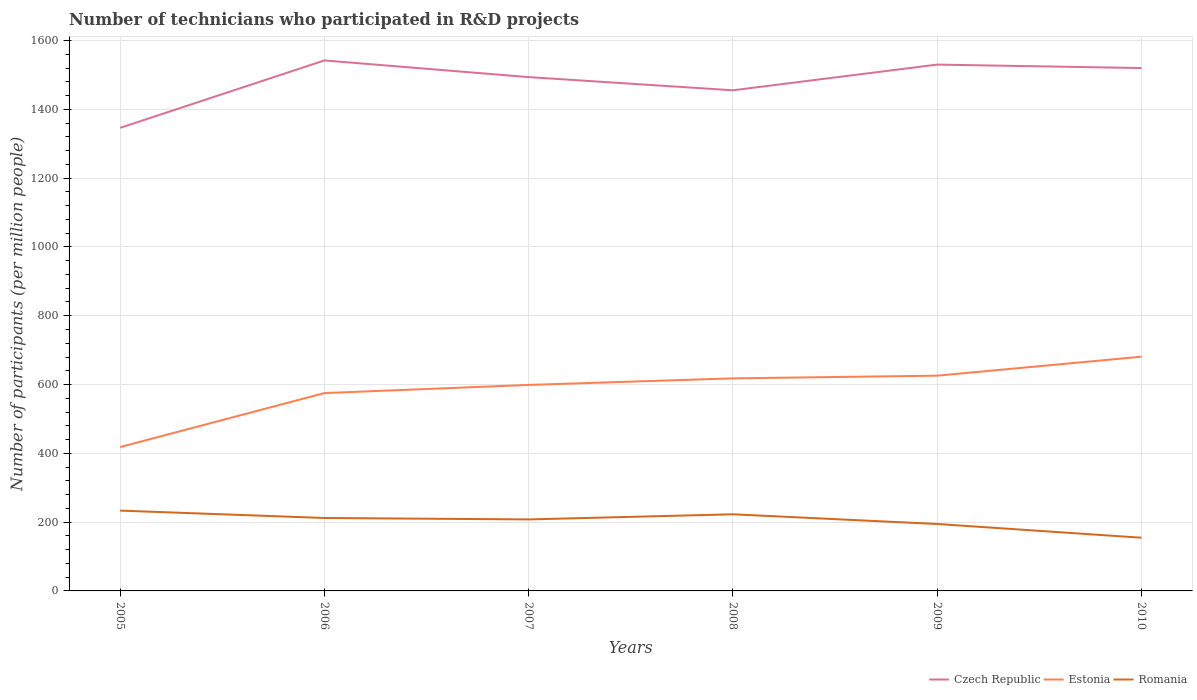How many different coloured lines are there?
Give a very brief answer. 3. Does the line corresponding to Estonia intersect with the line corresponding to Czech Republic?
Your response must be concise. No. Across all years, what is the maximum number of technicians who participated in R&D projects in Estonia?
Provide a short and direct response. 418.25. In which year was the number of technicians who participated in R&D projects in Estonia maximum?
Give a very brief answer. 2005. What is the total number of technicians who participated in R&D projects in Romania in the graph?
Make the answer very short. 68.1. What is the difference between the highest and the second highest number of technicians who participated in R&D projects in Czech Republic?
Provide a succinct answer. 195.97. What is the difference between the highest and the lowest number of technicians who participated in R&D projects in Czech Republic?
Make the answer very short. 4. Is the number of technicians who participated in R&D projects in Estonia strictly greater than the number of technicians who participated in R&D projects in Czech Republic over the years?
Keep it short and to the point. Yes. How many lines are there?
Provide a short and direct response. 3. Are the values on the major ticks of Y-axis written in scientific E-notation?
Keep it short and to the point. No. Where does the legend appear in the graph?
Your answer should be very brief. Bottom right. How many legend labels are there?
Your response must be concise. 3. How are the legend labels stacked?
Offer a very short reply. Horizontal. What is the title of the graph?
Provide a succinct answer. Number of technicians who participated in R&D projects. Does "Tanzania" appear as one of the legend labels in the graph?
Your response must be concise. No. What is the label or title of the Y-axis?
Give a very brief answer. Number of participants (per million people). What is the Number of participants (per million people) of Czech Republic in 2005?
Provide a short and direct response. 1346.19. What is the Number of participants (per million people) in Estonia in 2005?
Your response must be concise. 418.25. What is the Number of participants (per million people) of Romania in 2005?
Provide a succinct answer. 233.47. What is the Number of participants (per million people) of Czech Republic in 2006?
Make the answer very short. 1542.15. What is the Number of participants (per million people) in Estonia in 2006?
Your answer should be very brief. 575.08. What is the Number of participants (per million people) in Romania in 2006?
Offer a terse response. 212.02. What is the Number of participants (per million people) of Czech Republic in 2007?
Provide a succinct answer. 1493.68. What is the Number of participants (per million people) of Estonia in 2007?
Keep it short and to the point. 598.85. What is the Number of participants (per million people) of Romania in 2007?
Keep it short and to the point. 207.87. What is the Number of participants (per million people) in Czech Republic in 2008?
Provide a short and direct response. 1455.38. What is the Number of participants (per million people) of Estonia in 2008?
Give a very brief answer. 617.94. What is the Number of participants (per million people) in Romania in 2008?
Offer a very short reply. 222.74. What is the Number of participants (per million people) of Czech Republic in 2009?
Provide a succinct answer. 1530.09. What is the Number of participants (per million people) of Estonia in 2009?
Offer a terse response. 625.74. What is the Number of participants (per million people) in Romania in 2009?
Offer a terse response. 194.59. What is the Number of participants (per million people) of Czech Republic in 2010?
Offer a terse response. 1520.06. What is the Number of participants (per million people) in Estonia in 2010?
Offer a very short reply. 680.89. What is the Number of participants (per million people) in Romania in 2010?
Your answer should be compact. 154.64. Across all years, what is the maximum Number of participants (per million people) of Czech Republic?
Provide a short and direct response. 1542.15. Across all years, what is the maximum Number of participants (per million people) of Estonia?
Offer a very short reply. 680.89. Across all years, what is the maximum Number of participants (per million people) in Romania?
Your response must be concise. 233.47. Across all years, what is the minimum Number of participants (per million people) in Czech Republic?
Your answer should be compact. 1346.19. Across all years, what is the minimum Number of participants (per million people) in Estonia?
Offer a very short reply. 418.25. Across all years, what is the minimum Number of participants (per million people) of Romania?
Offer a very short reply. 154.64. What is the total Number of participants (per million people) of Czech Republic in the graph?
Your answer should be very brief. 8887.55. What is the total Number of participants (per million people) of Estonia in the graph?
Your answer should be compact. 3516.75. What is the total Number of participants (per million people) in Romania in the graph?
Your answer should be compact. 1225.32. What is the difference between the Number of participants (per million people) in Czech Republic in 2005 and that in 2006?
Offer a terse response. -195.97. What is the difference between the Number of participants (per million people) of Estonia in 2005 and that in 2006?
Offer a terse response. -156.84. What is the difference between the Number of participants (per million people) in Romania in 2005 and that in 2006?
Your response must be concise. 21.45. What is the difference between the Number of participants (per million people) of Czech Republic in 2005 and that in 2007?
Make the answer very short. -147.5. What is the difference between the Number of participants (per million people) of Estonia in 2005 and that in 2007?
Your answer should be very brief. -180.61. What is the difference between the Number of participants (per million people) in Romania in 2005 and that in 2007?
Your response must be concise. 25.6. What is the difference between the Number of participants (per million people) in Czech Republic in 2005 and that in 2008?
Give a very brief answer. -109.19. What is the difference between the Number of participants (per million people) of Estonia in 2005 and that in 2008?
Your answer should be very brief. -199.69. What is the difference between the Number of participants (per million people) of Romania in 2005 and that in 2008?
Make the answer very short. 10.73. What is the difference between the Number of participants (per million people) in Czech Republic in 2005 and that in 2009?
Keep it short and to the point. -183.91. What is the difference between the Number of participants (per million people) in Estonia in 2005 and that in 2009?
Ensure brevity in your answer.  -207.5. What is the difference between the Number of participants (per million people) of Romania in 2005 and that in 2009?
Keep it short and to the point. 38.88. What is the difference between the Number of participants (per million people) of Czech Republic in 2005 and that in 2010?
Offer a terse response. -173.87. What is the difference between the Number of participants (per million people) of Estonia in 2005 and that in 2010?
Give a very brief answer. -262.64. What is the difference between the Number of participants (per million people) of Romania in 2005 and that in 2010?
Provide a succinct answer. 78.83. What is the difference between the Number of participants (per million people) in Czech Republic in 2006 and that in 2007?
Your answer should be compact. 48.47. What is the difference between the Number of participants (per million people) in Estonia in 2006 and that in 2007?
Your answer should be very brief. -23.77. What is the difference between the Number of participants (per million people) in Romania in 2006 and that in 2007?
Provide a short and direct response. 4.15. What is the difference between the Number of participants (per million people) in Czech Republic in 2006 and that in 2008?
Provide a succinct answer. 86.78. What is the difference between the Number of participants (per million people) of Estonia in 2006 and that in 2008?
Your response must be concise. -42.85. What is the difference between the Number of participants (per million people) of Romania in 2006 and that in 2008?
Offer a terse response. -10.72. What is the difference between the Number of participants (per million people) in Czech Republic in 2006 and that in 2009?
Offer a very short reply. 12.06. What is the difference between the Number of participants (per million people) of Estonia in 2006 and that in 2009?
Ensure brevity in your answer.  -50.66. What is the difference between the Number of participants (per million people) in Romania in 2006 and that in 2009?
Your answer should be compact. 17.43. What is the difference between the Number of participants (per million people) of Czech Republic in 2006 and that in 2010?
Offer a very short reply. 22.1. What is the difference between the Number of participants (per million people) in Estonia in 2006 and that in 2010?
Keep it short and to the point. -105.8. What is the difference between the Number of participants (per million people) of Romania in 2006 and that in 2010?
Keep it short and to the point. 57.38. What is the difference between the Number of participants (per million people) in Czech Republic in 2007 and that in 2008?
Offer a very short reply. 38.3. What is the difference between the Number of participants (per million people) of Estonia in 2007 and that in 2008?
Make the answer very short. -19.08. What is the difference between the Number of participants (per million people) of Romania in 2007 and that in 2008?
Offer a terse response. -14.87. What is the difference between the Number of participants (per million people) of Czech Republic in 2007 and that in 2009?
Give a very brief answer. -36.41. What is the difference between the Number of participants (per million people) in Estonia in 2007 and that in 2009?
Keep it short and to the point. -26.89. What is the difference between the Number of participants (per million people) in Romania in 2007 and that in 2009?
Provide a succinct answer. 13.28. What is the difference between the Number of participants (per million people) in Czech Republic in 2007 and that in 2010?
Offer a terse response. -26.38. What is the difference between the Number of participants (per million people) in Estonia in 2007 and that in 2010?
Your answer should be very brief. -82.03. What is the difference between the Number of participants (per million people) in Romania in 2007 and that in 2010?
Give a very brief answer. 53.23. What is the difference between the Number of participants (per million people) of Czech Republic in 2008 and that in 2009?
Keep it short and to the point. -74.72. What is the difference between the Number of participants (per million people) of Estonia in 2008 and that in 2009?
Ensure brevity in your answer.  -7.8. What is the difference between the Number of participants (per million people) of Romania in 2008 and that in 2009?
Your answer should be very brief. 28.15. What is the difference between the Number of participants (per million people) in Czech Republic in 2008 and that in 2010?
Your answer should be very brief. -64.68. What is the difference between the Number of participants (per million people) of Estonia in 2008 and that in 2010?
Keep it short and to the point. -62.95. What is the difference between the Number of participants (per million people) in Romania in 2008 and that in 2010?
Offer a very short reply. 68.1. What is the difference between the Number of participants (per million people) of Czech Republic in 2009 and that in 2010?
Offer a terse response. 10.04. What is the difference between the Number of participants (per million people) in Estonia in 2009 and that in 2010?
Offer a terse response. -55.14. What is the difference between the Number of participants (per million people) in Romania in 2009 and that in 2010?
Provide a short and direct response. 39.95. What is the difference between the Number of participants (per million people) in Czech Republic in 2005 and the Number of participants (per million people) in Estonia in 2006?
Keep it short and to the point. 771.1. What is the difference between the Number of participants (per million people) of Czech Republic in 2005 and the Number of participants (per million people) of Romania in 2006?
Your answer should be very brief. 1134.17. What is the difference between the Number of participants (per million people) in Estonia in 2005 and the Number of participants (per million people) in Romania in 2006?
Your response must be concise. 206.23. What is the difference between the Number of participants (per million people) in Czech Republic in 2005 and the Number of participants (per million people) in Estonia in 2007?
Ensure brevity in your answer.  747.33. What is the difference between the Number of participants (per million people) in Czech Republic in 2005 and the Number of participants (per million people) in Romania in 2007?
Your response must be concise. 1138.32. What is the difference between the Number of participants (per million people) of Estonia in 2005 and the Number of participants (per million people) of Romania in 2007?
Make the answer very short. 210.38. What is the difference between the Number of participants (per million people) of Czech Republic in 2005 and the Number of participants (per million people) of Estonia in 2008?
Give a very brief answer. 728.25. What is the difference between the Number of participants (per million people) in Czech Republic in 2005 and the Number of participants (per million people) in Romania in 2008?
Ensure brevity in your answer.  1123.45. What is the difference between the Number of participants (per million people) in Estonia in 2005 and the Number of participants (per million people) in Romania in 2008?
Provide a succinct answer. 195.51. What is the difference between the Number of participants (per million people) of Czech Republic in 2005 and the Number of participants (per million people) of Estonia in 2009?
Give a very brief answer. 720.44. What is the difference between the Number of participants (per million people) of Czech Republic in 2005 and the Number of participants (per million people) of Romania in 2009?
Provide a succinct answer. 1151.6. What is the difference between the Number of participants (per million people) in Estonia in 2005 and the Number of participants (per million people) in Romania in 2009?
Offer a very short reply. 223.66. What is the difference between the Number of participants (per million people) of Czech Republic in 2005 and the Number of participants (per million people) of Estonia in 2010?
Ensure brevity in your answer.  665.3. What is the difference between the Number of participants (per million people) of Czech Republic in 2005 and the Number of participants (per million people) of Romania in 2010?
Make the answer very short. 1191.55. What is the difference between the Number of participants (per million people) of Estonia in 2005 and the Number of participants (per million people) of Romania in 2010?
Give a very brief answer. 263.61. What is the difference between the Number of participants (per million people) in Czech Republic in 2006 and the Number of participants (per million people) in Estonia in 2007?
Make the answer very short. 943.3. What is the difference between the Number of participants (per million people) in Czech Republic in 2006 and the Number of participants (per million people) in Romania in 2007?
Offer a terse response. 1334.29. What is the difference between the Number of participants (per million people) of Estonia in 2006 and the Number of participants (per million people) of Romania in 2007?
Provide a succinct answer. 367.22. What is the difference between the Number of participants (per million people) of Czech Republic in 2006 and the Number of participants (per million people) of Estonia in 2008?
Provide a short and direct response. 924.22. What is the difference between the Number of participants (per million people) of Czech Republic in 2006 and the Number of participants (per million people) of Romania in 2008?
Ensure brevity in your answer.  1319.41. What is the difference between the Number of participants (per million people) in Estonia in 2006 and the Number of participants (per million people) in Romania in 2008?
Provide a succinct answer. 352.34. What is the difference between the Number of participants (per million people) in Czech Republic in 2006 and the Number of participants (per million people) in Estonia in 2009?
Make the answer very short. 916.41. What is the difference between the Number of participants (per million people) in Czech Republic in 2006 and the Number of participants (per million people) in Romania in 2009?
Provide a short and direct response. 1347.57. What is the difference between the Number of participants (per million people) in Estonia in 2006 and the Number of participants (per million people) in Romania in 2009?
Ensure brevity in your answer.  380.5. What is the difference between the Number of participants (per million people) of Czech Republic in 2006 and the Number of participants (per million people) of Estonia in 2010?
Keep it short and to the point. 861.27. What is the difference between the Number of participants (per million people) of Czech Republic in 2006 and the Number of participants (per million people) of Romania in 2010?
Your answer should be compact. 1387.51. What is the difference between the Number of participants (per million people) of Estonia in 2006 and the Number of participants (per million people) of Romania in 2010?
Keep it short and to the point. 420.44. What is the difference between the Number of participants (per million people) in Czech Republic in 2007 and the Number of participants (per million people) in Estonia in 2008?
Provide a short and direct response. 875.74. What is the difference between the Number of participants (per million people) of Czech Republic in 2007 and the Number of participants (per million people) of Romania in 2008?
Make the answer very short. 1270.94. What is the difference between the Number of participants (per million people) of Estonia in 2007 and the Number of participants (per million people) of Romania in 2008?
Give a very brief answer. 376.11. What is the difference between the Number of participants (per million people) of Czech Republic in 2007 and the Number of participants (per million people) of Estonia in 2009?
Keep it short and to the point. 867.94. What is the difference between the Number of participants (per million people) of Czech Republic in 2007 and the Number of participants (per million people) of Romania in 2009?
Offer a terse response. 1299.1. What is the difference between the Number of participants (per million people) in Estonia in 2007 and the Number of participants (per million people) in Romania in 2009?
Provide a succinct answer. 404.27. What is the difference between the Number of participants (per million people) of Czech Republic in 2007 and the Number of participants (per million people) of Estonia in 2010?
Provide a short and direct response. 812.8. What is the difference between the Number of participants (per million people) in Czech Republic in 2007 and the Number of participants (per million people) in Romania in 2010?
Provide a short and direct response. 1339.04. What is the difference between the Number of participants (per million people) in Estonia in 2007 and the Number of participants (per million people) in Romania in 2010?
Make the answer very short. 444.22. What is the difference between the Number of participants (per million people) in Czech Republic in 2008 and the Number of participants (per million people) in Estonia in 2009?
Provide a short and direct response. 829.63. What is the difference between the Number of participants (per million people) of Czech Republic in 2008 and the Number of participants (per million people) of Romania in 2009?
Offer a terse response. 1260.79. What is the difference between the Number of participants (per million people) of Estonia in 2008 and the Number of participants (per million people) of Romania in 2009?
Keep it short and to the point. 423.35. What is the difference between the Number of participants (per million people) of Czech Republic in 2008 and the Number of participants (per million people) of Estonia in 2010?
Your answer should be very brief. 774.49. What is the difference between the Number of participants (per million people) in Czech Republic in 2008 and the Number of participants (per million people) in Romania in 2010?
Ensure brevity in your answer.  1300.74. What is the difference between the Number of participants (per million people) of Estonia in 2008 and the Number of participants (per million people) of Romania in 2010?
Ensure brevity in your answer.  463.3. What is the difference between the Number of participants (per million people) in Czech Republic in 2009 and the Number of participants (per million people) in Estonia in 2010?
Ensure brevity in your answer.  849.21. What is the difference between the Number of participants (per million people) in Czech Republic in 2009 and the Number of participants (per million people) in Romania in 2010?
Ensure brevity in your answer.  1375.45. What is the difference between the Number of participants (per million people) in Estonia in 2009 and the Number of participants (per million people) in Romania in 2010?
Make the answer very short. 471.1. What is the average Number of participants (per million people) of Czech Republic per year?
Provide a short and direct response. 1481.26. What is the average Number of participants (per million people) of Estonia per year?
Provide a succinct answer. 586.12. What is the average Number of participants (per million people) of Romania per year?
Offer a very short reply. 204.22. In the year 2005, what is the difference between the Number of participants (per million people) of Czech Republic and Number of participants (per million people) of Estonia?
Make the answer very short. 927.94. In the year 2005, what is the difference between the Number of participants (per million people) of Czech Republic and Number of participants (per million people) of Romania?
Your answer should be compact. 1112.72. In the year 2005, what is the difference between the Number of participants (per million people) of Estonia and Number of participants (per million people) of Romania?
Your answer should be very brief. 184.78. In the year 2006, what is the difference between the Number of participants (per million people) in Czech Republic and Number of participants (per million people) in Estonia?
Give a very brief answer. 967.07. In the year 2006, what is the difference between the Number of participants (per million people) in Czech Republic and Number of participants (per million people) in Romania?
Ensure brevity in your answer.  1330.14. In the year 2006, what is the difference between the Number of participants (per million people) in Estonia and Number of participants (per million people) in Romania?
Offer a very short reply. 363.07. In the year 2007, what is the difference between the Number of participants (per million people) in Czech Republic and Number of participants (per million people) in Estonia?
Your answer should be very brief. 894.83. In the year 2007, what is the difference between the Number of participants (per million people) of Czech Republic and Number of participants (per million people) of Romania?
Give a very brief answer. 1285.81. In the year 2007, what is the difference between the Number of participants (per million people) in Estonia and Number of participants (per million people) in Romania?
Ensure brevity in your answer.  390.99. In the year 2008, what is the difference between the Number of participants (per million people) in Czech Republic and Number of participants (per million people) in Estonia?
Offer a terse response. 837.44. In the year 2008, what is the difference between the Number of participants (per million people) of Czech Republic and Number of participants (per million people) of Romania?
Offer a terse response. 1232.64. In the year 2008, what is the difference between the Number of participants (per million people) in Estonia and Number of participants (per million people) in Romania?
Ensure brevity in your answer.  395.2. In the year 2009, what is the difference between the Number of participants (per million people) of Czech Republic and Number of participants (per million people) of Estonia?
Your response must be concise. 904.35. In the year 2009, what is the difference between the Number of participants (per million people) in Czech Republic and Number of participants (per million people) in Romania?
Provide a short and direct response. 1335.51. In the year 2009, what is the difference between the Number of participants (per million people) of Estonia and Number of participants (per million people) of Romania?
Your response must be concise. 431.16. In the year 2010, what is the difference between the Number of participants (per million people) of Czech Republic and Number of participants (per million people) of Estonia?
Provide a succinct answer. 839.17. In the year 2010, what is the difference between the Number of participants (per million people) in Czech Republic and Number of participants (per million people) in Romania?
Provide a short and direct response. 1365.42. In the year 2010, what is the difference between the Number of participants (per million people) in Estonia and Number of participants (per million people) in Romania?
Your answer should be compact. 526.25. What is the ratio of the Number of participants (per million people) in Czech Republic in 2005 to that in 2006?
Your response must be concise. 0.87. What is the ratio of the Number of participants (per million people) in Estonia in 2005 to that in 2006?
Give a very brief answer. 0.73. What is the ratio of the Number of participants (per million people) in Romania in 2005 to that in 2006?
Your answer should be compact. 1.1. What is the ratio of the Number of participants (per million people) in Czech Republic in 2005 to that in 2007?
Make the answer very short. 0.9. What is the ratio of the Number of participants (per million people) in Estonia in 2005 to that in 2007?
Give a very brief answer. 0.7. What is the ratio of the Number of participants (per million people) of Romania in 2005 to that in 2007?
Your answer should be compact. 1.12. What is the ratio of the Number of participants (per million people) of Czech Republic in 2005 to that in 2008?
Your answer should be compact. 0.93. What is the ratio of the Number of participants (per million people) of Estonia in 2005 to that in 2008?
Your answer should be compact. 0.68. What is the ratio of the Number of participants (per million people) of Romania in 2005 to that in 2008?
Offer a very short reply. 1.05. What is the ratio of the Number of participants (per million people) in Czech Republic in 2005 to that in 2009?
Your answer should be very brief. 0.88. What is the ratio of the Number of participants (per million people) in Estonia in 2005 to that in 2009?
Your answer should be very brief. 0.67. What is the ratio of the Number of participants (per million people) in Romania in 2005 to that in 2009?
Your answer should be very brief. 1.2. What is the ratio of the Number of participants (per million people) of Czech Republic in 2005 to that in 2010?
Keep it short and to the point. 0.89. What is the ratio of the Number of participants (per million people) in Estonia in 2005 to that in 2010?
Give a very brief answer. 0.61. What is the ratio of the Number of participants (per million people) in Romania in 2005 to that in 2010?
Give a very brief answer. 1.51. What is the ratio of the Number of participants (per million people) of Czech Republic in 2006 to that in 2007?
Your answer should be very brief. 1.03. What is the ratio of the Number of participants (per million people) of Estonia in 2006 to that in 2007?
Make the answer very short. 0.96. What is the ratio of the Number of participants (per million people) of Czech Republic in 2006 to that in 2008?
Ensure brevity in your answer.  1.06. What is the ratio of the Number of participants (per million people) of Estonia in 2006 to that in 2008?
Offer a terse response. 0.93. What is the ratio of the Number of participants (per million people) in Romania in 2006 to that in 2008?
Provide a succinct answer. 0.95. What is the ratio of the Number of participants (per million people) of Czech Republic in 2006 to that in 2009?
Provide a succinct answer. 1.01. What is the ratio of the Number of participants (per million people) in Estonia in 2006 to that in 2009?
Offer a very short reply. 0.92. What is the ratio of the Number of participants (per million people) of Romania in 2006 to that in 2009?
Offer a terse response. 1.09. What is the ratio of the Number of participants (per million people) of Czech Republic in 2006 to that in 2010?
Your response must be concise. 1.01. What is the ratio of the Number of participants (per million people) of Estonia in 2006 to that in 2010?
Provide a succinct answer. 0.84. What is the ratio of the Number of participants (per million people) in Romania in 2006 to that in 2010?
Offer a very short reply. 1.37. What is the ratio of the Number of participants (per million people) in Czech Republic in 2007 to that in 2008?
Keep it short and to the point. 1.03. What is the ratio of the Number of participants (per million people) in Estonia in 2007 to that in 2008?
Offer a terse response. 0.97. What is the ratio of the Number of participants (per million people) in Romania in 2007 to that in 2008?
Provide a short and direct response. 0.93. What is the ratio of the Number of participants (per million people) in Czech Republic in 2007 to that in 2009?
Make the answer very short. 0.98. What is the ratio of the Number of participants (per million people) of Romania in 2007 to that in 2009?
Your answer should be compact. 1.07. What is the ratio of the Number of participants (per million people) of Czech Republic in 2007 to that in 2010?
Your response must be concise. 0.98. What is the ratio of the Number of participants (per million people) in Estonia in 2007 to that in 2010?
Provide a short and direct response. 0.88. What is the ratio of the Number of participants (per million people) of Romania in 2007 to that in 2010?
Make the answer very short. 1.34. What is the ratio of the Number of participants (per million people) of Czech Republic in 2008 to that in 2009?
Provide a short and direct response. 0.95. What is the ratio of the Number of participants (per million people) in Estonia in 2008 to that in 2009?
Your answer should be very brief. 0.99. What is the ratio of the Number of participants (per million people) in Romania in 2008 to that in 2009?
Provide a succinct answer. 1.14. What is the ratio of the Number of participants (per million people) of Czech Republic in 2008 to that in 2010?
Your response must be concise. 0.96. What is the ratio of the Number of participants (per million people) in Estonia in 2008 to that in 2010?
Your answer should be compact. 0.91. What is the ratio of the Number of participants (per million people) in Romania in 2008 to that in 2010?
Your response must be concise. 1.44. What is the ratio of the Number of participants (per million people) of Czech Republic in 2009 to that in 2010?
Keep it short and to the point. 1.01. What is the ratio of the Number of participants (per million people) in Estonia in 2009 to that in 2010?
Your answer should be very brief. 0.92. What is the ratio of the Number of participants (per million people) in Romania in 2009 to that in 2010?
Make the answer very short. 1.26. What is the difference between the highest and the second highest Number of participants (per million people) in Czech Republic?
Your answer should be compact. 12.06. What is the difference between the highest and the second highest Number of participants (per million people) of Estonia?
Offer a terse response. 55.14. What is the difference between the highest and the second highest Number of participants (per million people) of Romania?
Offer a very short reply. 10.73. What is the difference between the highest and the lowest Number of participants (per million people) of Czech Republic?
Ensure brevity in your answer.  195.97. What is the difference between the highest and the lowest Number of participants (per million people) of Estonia?
Give a very brief answer. 262.64. What is the difference between the highest and the lowest Number of participants (per million people) in Romania?
Your response must be concise. 78.83. 